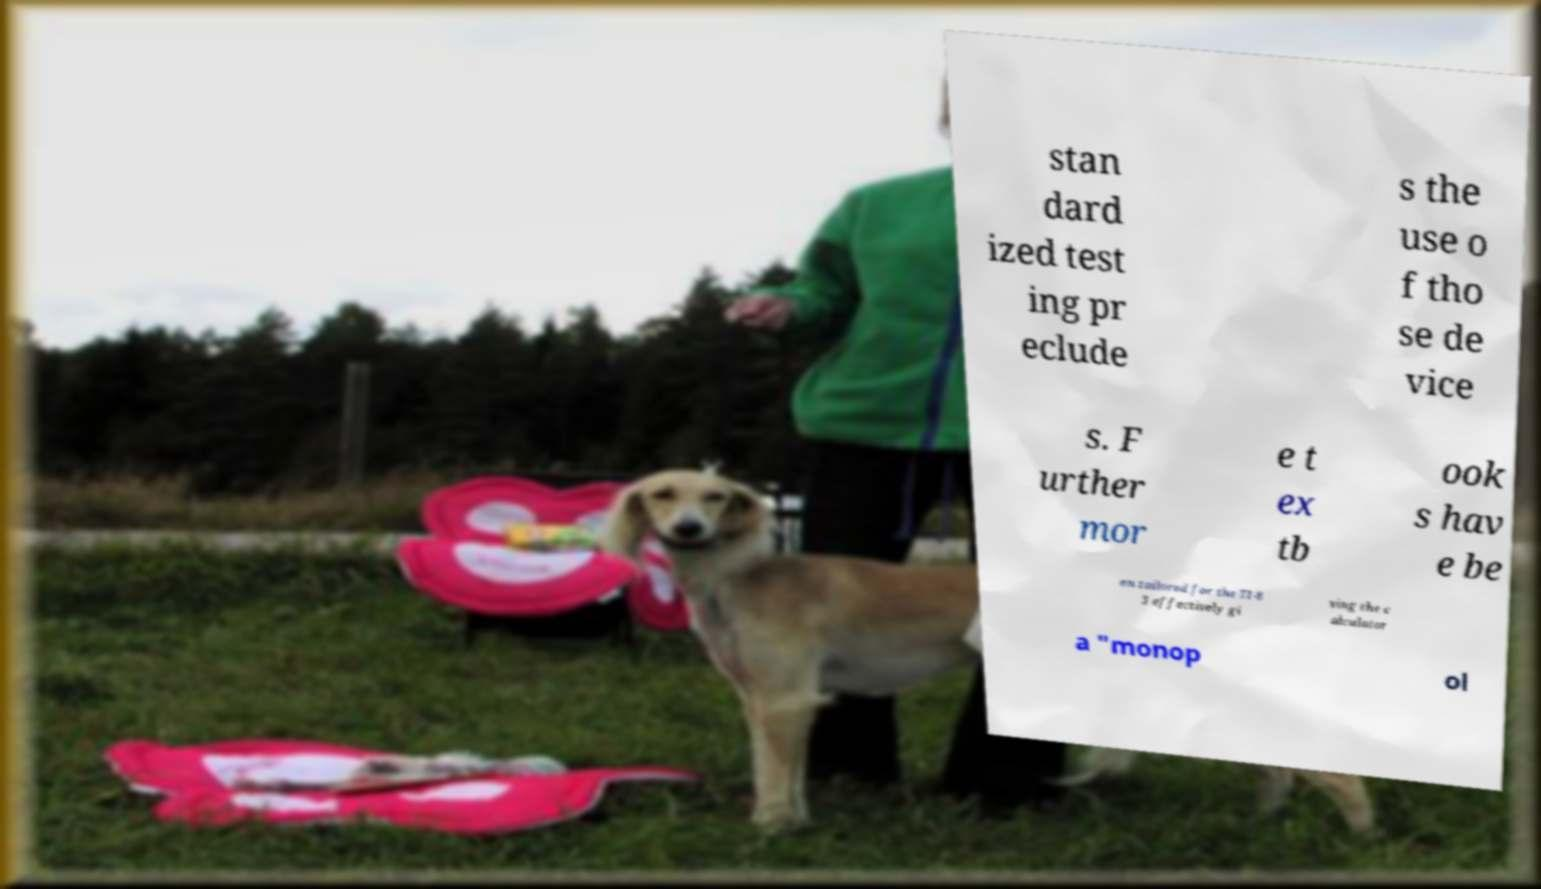Please read and relay the text visible in this image. What does it say? stan dard ized test ing pr eclude s the use o f tho se de vice s. F urther mor e t ex tb ook s hav e be en tailored for the TI-8 3 effectively gi ving the c alculator a "monop ol 